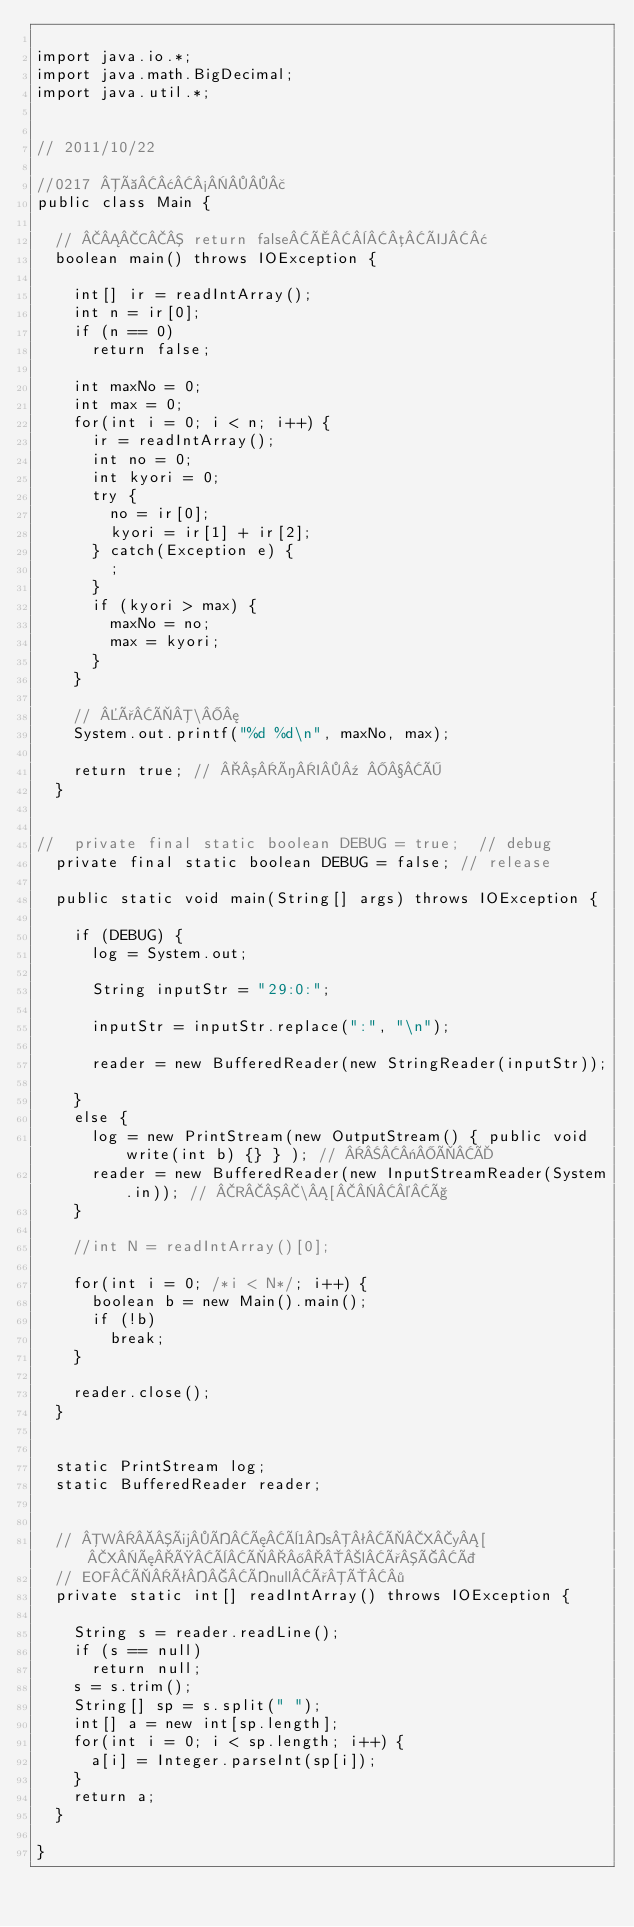<code> <loc_0><loc_0><loc_500><loc_500><_Java_>
import java.io.*;
import java.math.BigDecimal;
import java.util.*;


// 2011/10/22

//0217 à¢½£
public class Main {

	// C return falseÅ¨µÜ¢
	boolean main() throws IOException {

		int[] ir = readIntArray();
		int n = ir[0];
		if (n == 0)
			return false;

		int maxNo = 0;
		int max = 0;
		for(int i = 0; i < n; i++) {
			ir = readIntArray();
			int no = 0;
			int kyori = 0;
			try {
				no = ir[0];
				kyori = ir[1] + ir[2];
			} catch(Exception e) {
				;
			}
			if (kyori > max) {
				maxNo = no;
				max = kyori;
			}
		}

		// ðÌ\¦
		System.out.printf("%d %d\n", maxNo, max);
		
		return true; // ³íI¹ Ö
	}
	

//	private final static boolean DEBUG = true;  // debug
	private final static boolean DEBUG = false; // release

	public static void main(String[] args) throws IOException {

		if (DEBUG) {
			log = System.out;
			
			String inputStr = "29:0:";

			inputStr = inputStr.replace(":", "\n");

			reader = new BufferedReader(new StringReader(inputStr)); 

		}
		else {
			log = new PrintStream(new OutputStream() { public void write(int b) {} } ); // «ÌÄ
			reader = new BufferedReader(new InputStreamReader(System.in)); // R\[©ç
		}
		
		//int N = readIntArray()[0];

		for(int i = 0; /*i < N*/; i++) {
			boolean b = new Main().main();
			if (!b)
				break;
		}		
		
		reader.close();
	}

	
	static PrintStream log;
	static BufferedReader reader;
	

	// WüÍæè1sªÌXy[XæØèÌ®lðÇÞ
	// EOFÌêÍnullðÔ·
	private static int[] readIntArray() throws IOException {
		
		String s = reader.readLine();
		if (s == null)
			return null;
		s = s.trim();
		String[] sp = s.split(" ");
		int[] a = new int[sp.length];
		for(int i = 0; i < sp.length; i++) {
			a[i] = Integer.parseInt(sp[i]);
		}
		return a;
	}
		
}</code> 